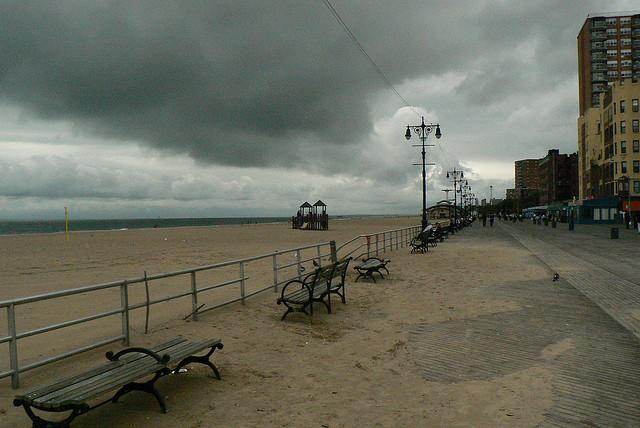Why is the beach empty? Please explain your reasoning. storm coming. The storm is coming. 